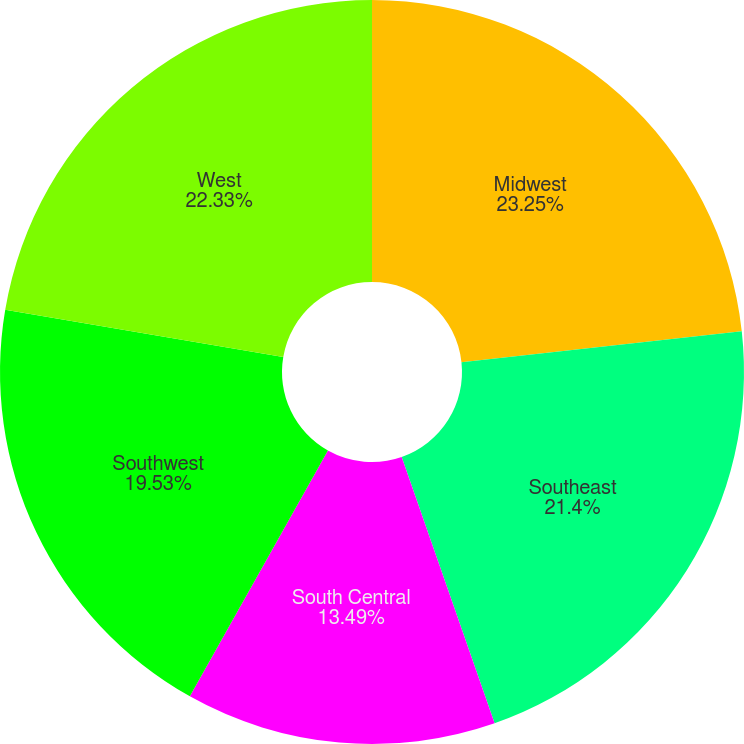<chart> <loc_0><loc_0><loc_500><loc_500><pie_chart><fcel>Midwest<fcel>Southeast<fcel>South Central<fcel>Southwest<fcel>West<nl><fcel>23.26%<fcel>21.4%<fcel>13.49%<fcel>19.53%<fcel>22.33%<nl></chart> 